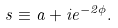<formula> <loc_0><loc_0><loc_500><loc_500>s \equiv a + i e ^ { - 2 \phi } .</formula> 